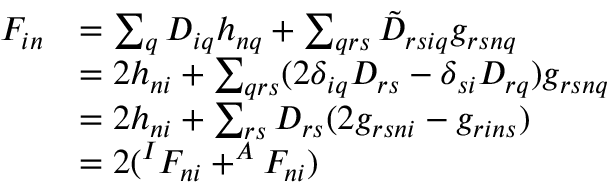Convert formula to latex. <formula><loc_0><loc_0><loc_500><loc_500>\begin{array} { r l } { F _ { i n } } & { = \sum _ { q } D _ { i q } h _ { n q } + \sum _ { q r s } \tilde { D } _ { r s i q } g _ { r s n q } } \\ & { = 2 h _ { n i } + \sum _ { q r s } ( 2 \delta _ { i q } D _ { r s } - \delta _ { s i } D _ { r q } ) g _ { r s n q } } \\ & { = 2 h _ { n i } + \sum _ { r s } D _ { r s } ( 2 g _ { r s n i } - g _ { r i n s } ) } \\ & { = 2 ( ^ { I } F _ { n i } + ^ { A } F _ { n i } ) } \end{array}</formula> 